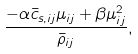Convert formula to latex. <formula><loc_0><loc_0><loc_500><loc_500>\frac { - \alpha \bar { c } _ { s , i j } \mu _ { i j } + \beta \mu ^ { 2 } _ { i j } } { \bar { \rho } _ { i j } } ,</formula> 